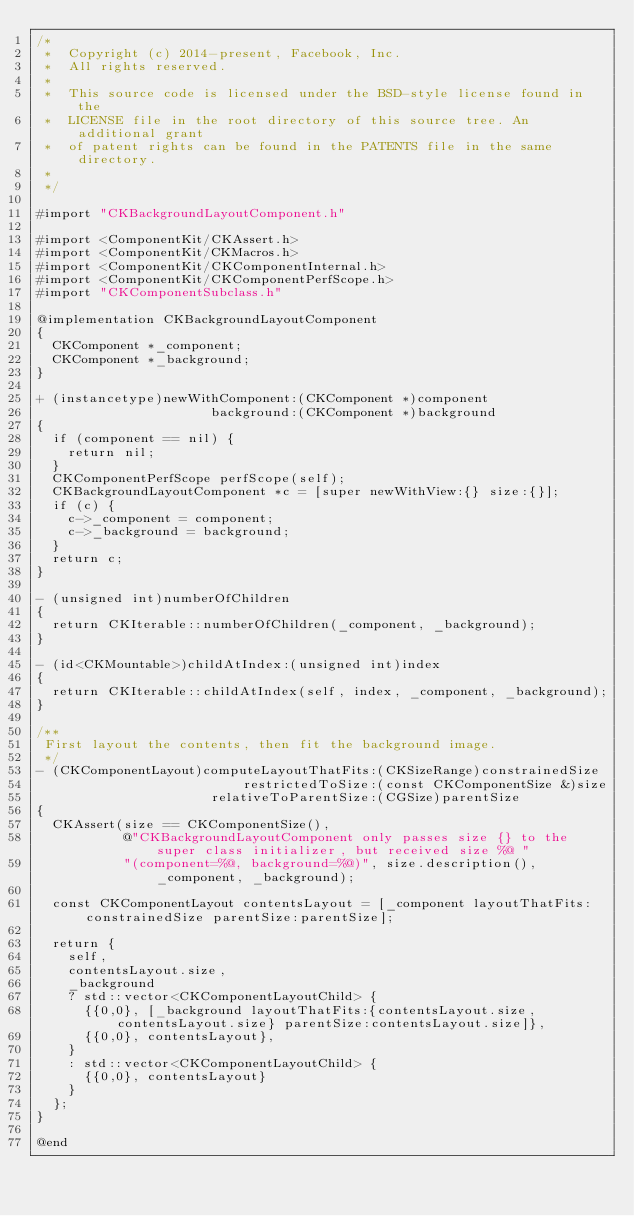Convert code to text. <code><loc_0><loc_0><loc_500><loc_500><_ObjectiveC_>/*
 *  Copyright (c) 2014-present, Facebook, Inc.
 *  All rights reserved.
 *
 *  This source code is licensed under the BSD-style license found in the
 *  LICENSE file in the root directory of this source tree. An additional grant
 *  of patent rights can be found in the PATENTS file in the same directory.
 *
 */

#import "CKBackgroundLayoutComponent.h"

#import <ComponentKit/CKAssert.h>
#import <ComponentKit/CKMacros.h>
#import <ComponentKit/CKComponentInternal.h>
#import <ComponentKit/CKComponentPerfScope.h>
#import "CKComponentSubclass.h"

@implementation CKBackgroundLayoutComponent
{
  CKComponent *_component;
  CKComponent *_background;
}

+ (instancetype)newWithComponent:(CKComponent *)component
                      background:(CKComponent *)background
{
  if (component == nil) {
    return nil;
  }
  CKComponentPerfScope perfScope(self);
  CKBackgroundLayoutComponent *c = [super newWithView:{} size:{}];
  if (c) {
    c->_component = component;
    c->_background = background;
  }
  return c;
}

- (unsigned int)numberOfChildren
{
  return CKIterable::numberOfChildren(_component, _background);
}

- (id<CKMountable>)childAtIndex:(unsigned int)index
{
  return CKIterable::childAtIndex(self, index, _component, _background);
}

/**
 First layout the contents, then fit the background image.
 */
- (CKComponentLayout)computeLayoutThatFits:(CKSizeRange)constrainedSize
                          restrictedToSize:(const CKComponentSize &)size
                      relativeToParentSize:(CGSize)parentSize
{
  CKAssert(size == CKComponentSize(),
           @"CKBackgroundLayoutComponent only passes size {} to the super class initializer, but received size %@ "
           "(component=%@, background=%@)", size.description(), _component, _background);

  const CKComponentLayout contentsLayout = [_component layoutThatFits:constrainedSize parentSize:parentSize];

  return {
    self,
    contentsLayout.size,
    _background
    ? std::vector<CKComponentLayoutChild> {
      {{0,0}, [_background layoutThatFits:{contentsLayout.size, contentsLayout.size} parentSize:contentsLayout.size]},
      {{0,0}, contentsLayout},
    }
    : std::vector<CKComponentLayoutChild> {
      {{0,0}, contentsLayout}
    }
  };
}

@end
</code> 